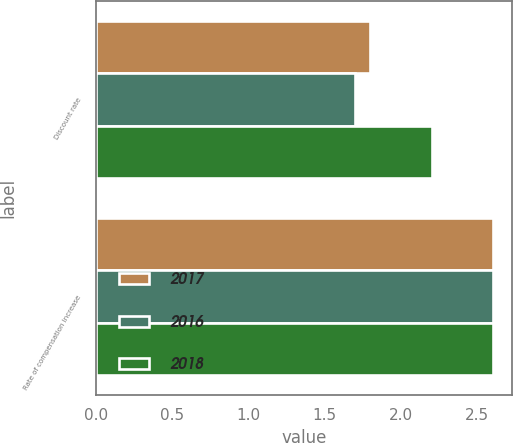Convert chart. <chart><loc_0><loc_0><loc_500><loc_500><stacked_bar_chart><ecel><fcel>Discount rate<fcel>Rate of compensation increase<nl><fcel>2017<fcel>1.8<fcel>2.6<nl><fcel>2016<fcel>1.7<fcel>2.6<nl><fcel>2018<fcel>2.2<fcel>2.6<nl></chart> 